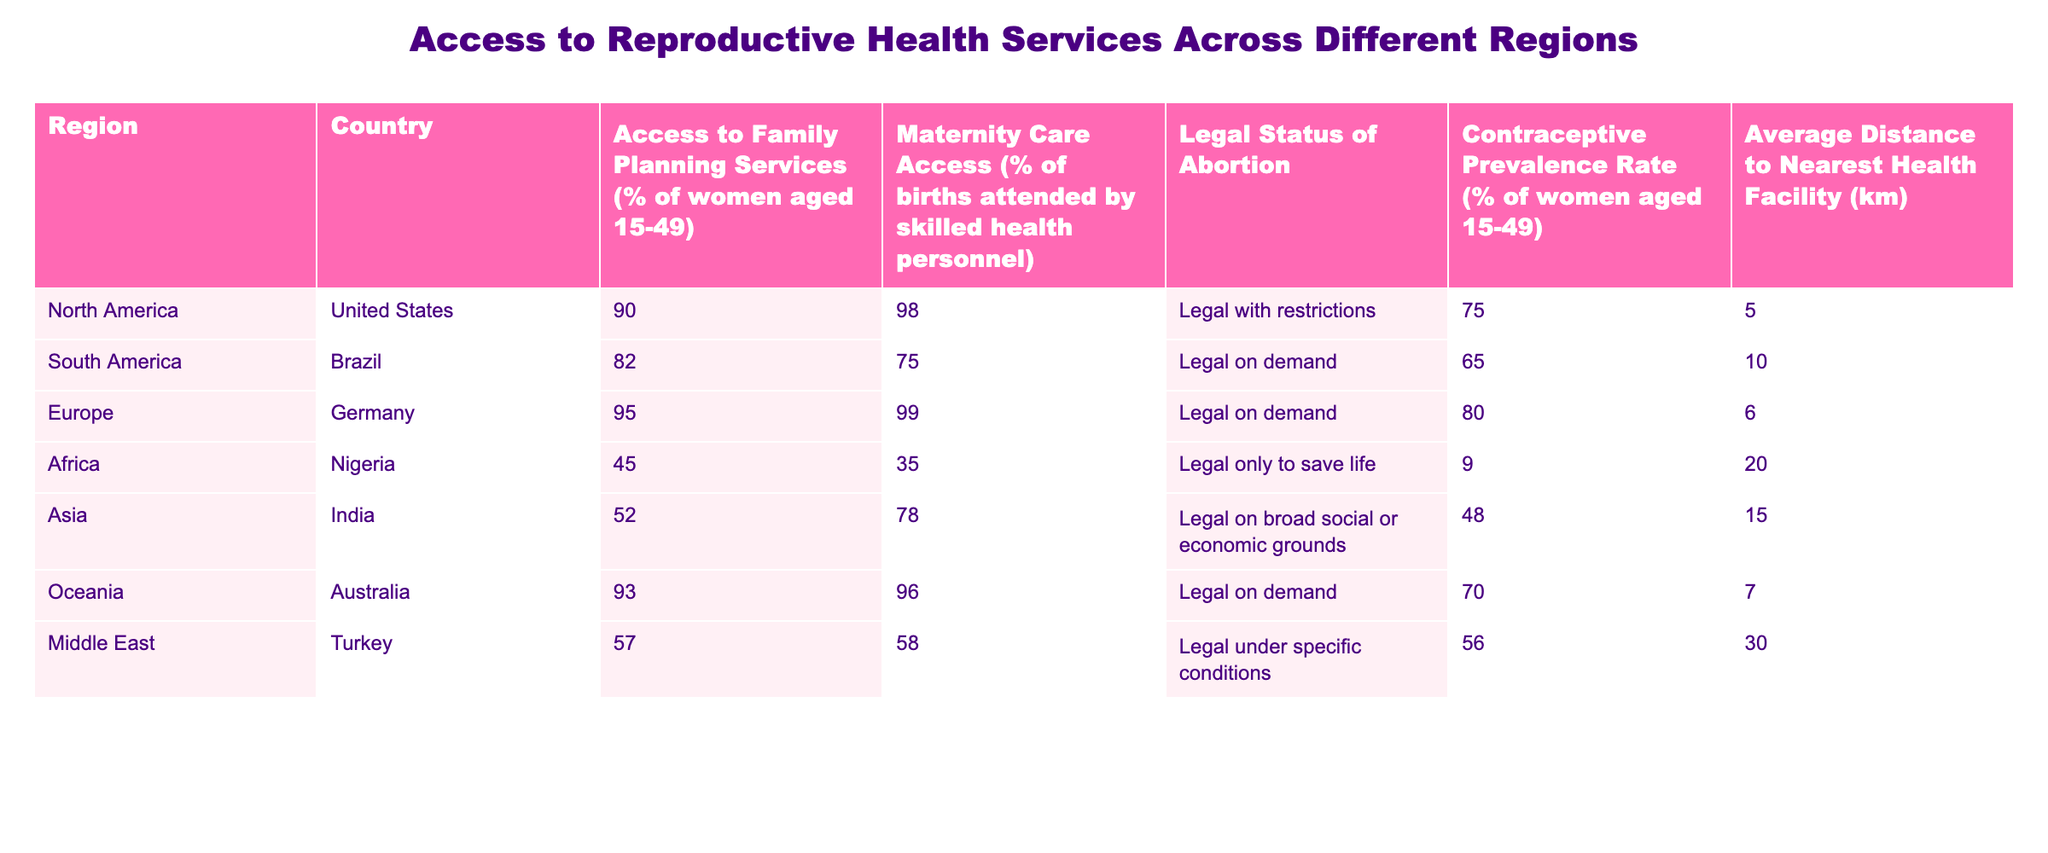What is the contraceptive prevalence rate in Nigeria? The table shows the contraceptive prevalence rate for Nigeria is provided in the corresponding row under "Contraceptive Prevalence Rate (% of women aged 15-49)", which is 9%.
Answer: 9% Which region has the highest access to maternity care services? By looking through the "Maternity Care Access (% of births attended by skilled health personnel)" column, I see that Germany has the highest percentage at 99%.
Answer: Germany Is access to family planning services above 80% in South America? The "Access to Family Planning Services (% of women aged 15-49)" for Brazil in South America is 82%, which is above 80%.
Answer: Yes Calculate the average distance to the nearest health facility for all regions. I sum the distances (5 + 10 + 6 + 20 + 15 + 7 + 30) = 93. There are 7 regions, so the average distance is 93 / 7 ≈ 13.29 km.
Answer: 13.29 km Is the legal status of abortion in Turkey more restrictive than in Nigeria? The table shows that Turkey allows abortion under specific conditions while Nigeria permits it only to save life. Therefore, Nigeria has a more restrictive legal status for abortion.
Answer: Yes What percentage of women aged 15-49 have access to family planning services in Oceania? The table indicates that in Australia, located in Oceania, 93% of women aged 15-49 have access to family planning services.
Answer: 93% How many countries in the table have maternity care access above 75%? The countries with maternity care access above 75% are: United States (98%), Germany (99%), and Australia (96%). In total, there are three such countries.
Answer: 3 Is the average access to family planning services in Asia below that of Europe? Looking at the access percentages, Asia (52% in India) is indeed below Europe (95% in Germany). Thus, the average access to family planning services in Asia is below that in Europe.
Answer: Yes What is the difference in contraceptive prevalence rates between the countries with the highest and lowest rates? Germany has the highest contraceptive prevalence rate at 80% and Nigeria has the lowest at 9%. The difference is 80% - 9% = 71%.
Answer: 71% 